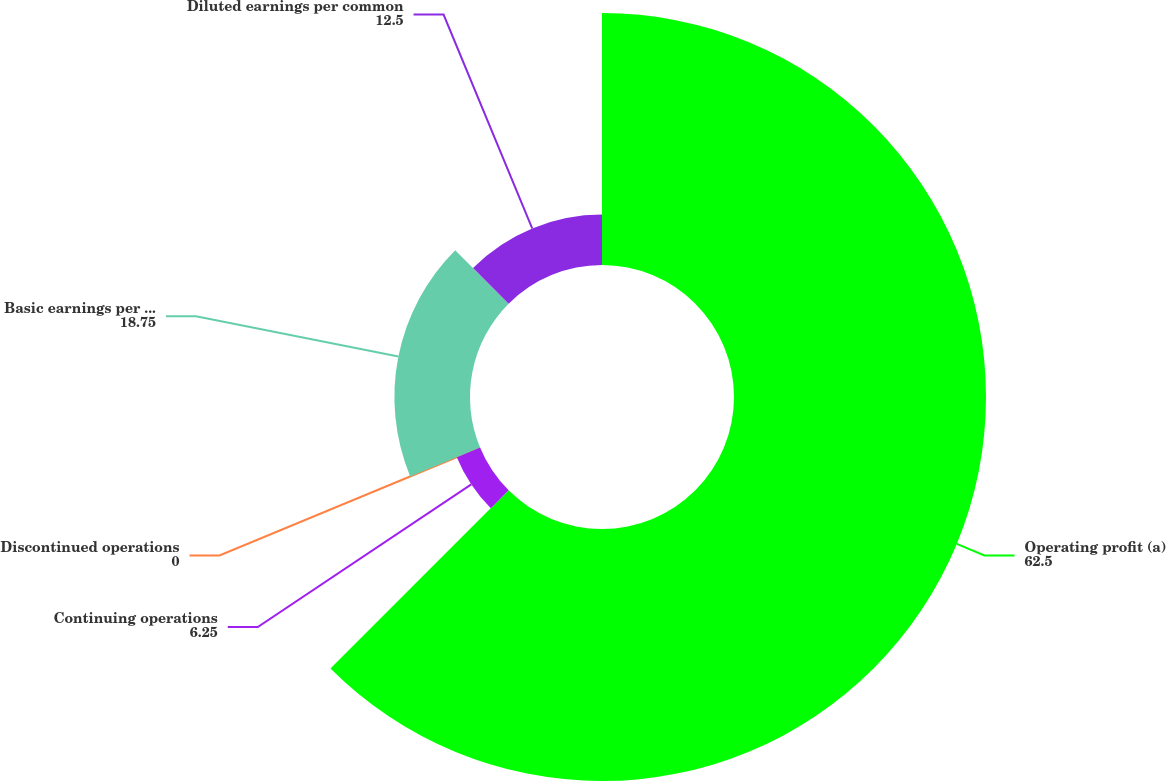Convert chart to OTSL. <chart><loc_0><loc_0><loc_500><loc_500><pie_chart><fcel>Operating profit (a)<fcel>Continuing operations<fcel>Discontinued operations<fcel>Basic earnings per common<fcel>Diluted earnings per common<nl><fcel>62.5%<fcel>6.25%<fcel>0.0%<fcel>18.75%<fcel>12.5%<nl></chart> 